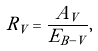<formula> <loc_0><loc_0><loc_500><loc_500>R _ { V } = \frac { A _ { V } } { E _ { B - V } } ,</formula> 